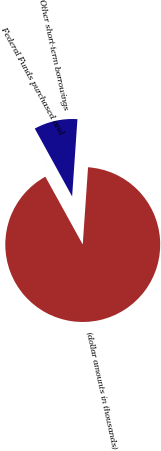Convert chart. <chart><loc_0><loc_0><loc_500><loc_500><pie_chart><fcel>(dollar amounts in thousands)<fcel>Federal Funds purchased and<fcel>Other short-term borrowings<nl><fcel>90.9%<fcel>0.01%<fcel>9.1%<nl></chart> 